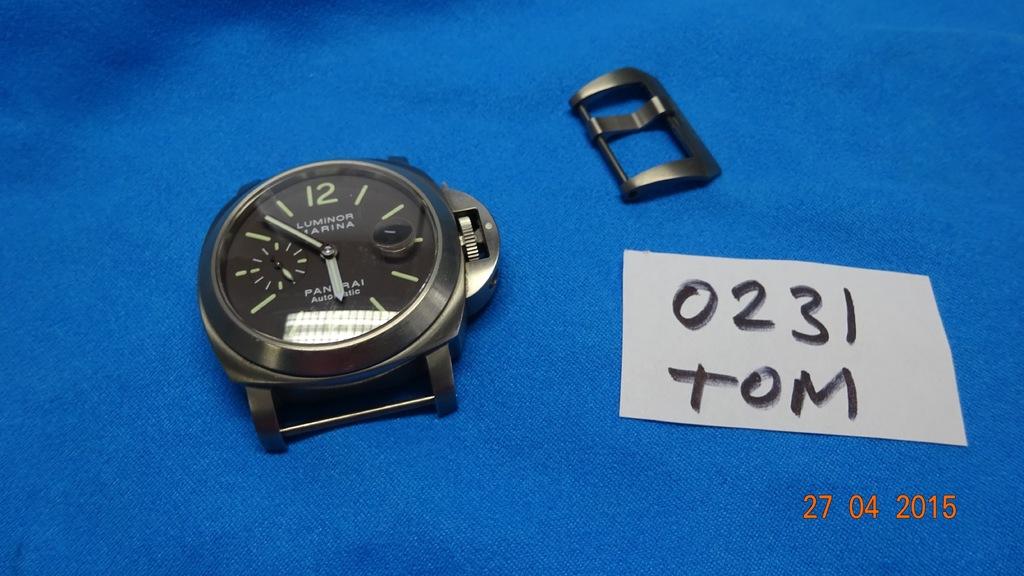When was this picture taken?
Your answer should be compact. 27 04 2015. What time is it on this watch?
Ensure brevity in your answer.  5:53. 